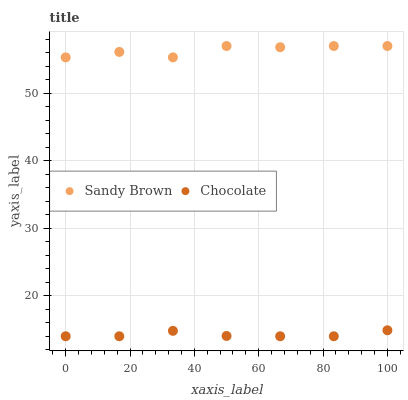Does Chocolate have the minimum area under the curve?
Answer yes or no. Yes. Does Sandy Brown have the maximum area under the curve?
Answer yes or no. Yes. Does Chocolate have the maximum area under the curve?
Answer yes or no. No. Is Chocolate the smoothest?
Answer yes or no. Yes. Is Sandy Brown the roughest?
Answer yes or no. Yes. Is Chocolate the roughest?
Answer yes or no. No. Does Chocolate have the lowest value?
Answer yes or no. Yes. Does Sandy Brown have the highest value?
Answer yes or no. Yes. Does Chocolate have the highest value?
Answer yes or no. No. Is Chocolate less than Sandy Brown?
Answer yes or no. Yes. Is Sandy Brown greater than Chocolate?
Answer yes or no. Yes. Does Chocolate intersect Sandy Brown?
Answer yes or no. No. 